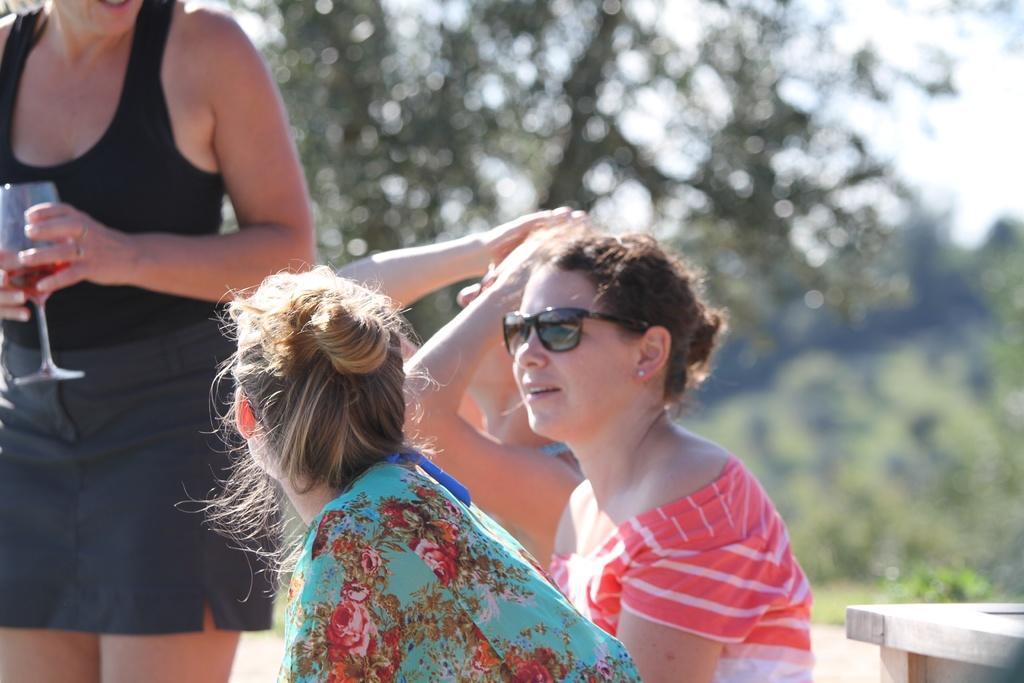Please provide a concise description of this image. In this picture we can see few people, on the left side of the image we can see a woman, she is holding a glass, in the background we can see few trees. 